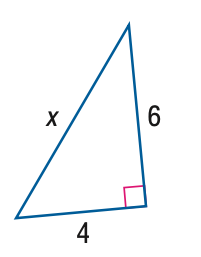Answer the mathemtical geometry problem and directly provide the correct option letter.
Question: Find x. Round to the nearest hundredth.
Choices: A: 4.47 B: 5.34 C: 6.54 D: 7.21 D 